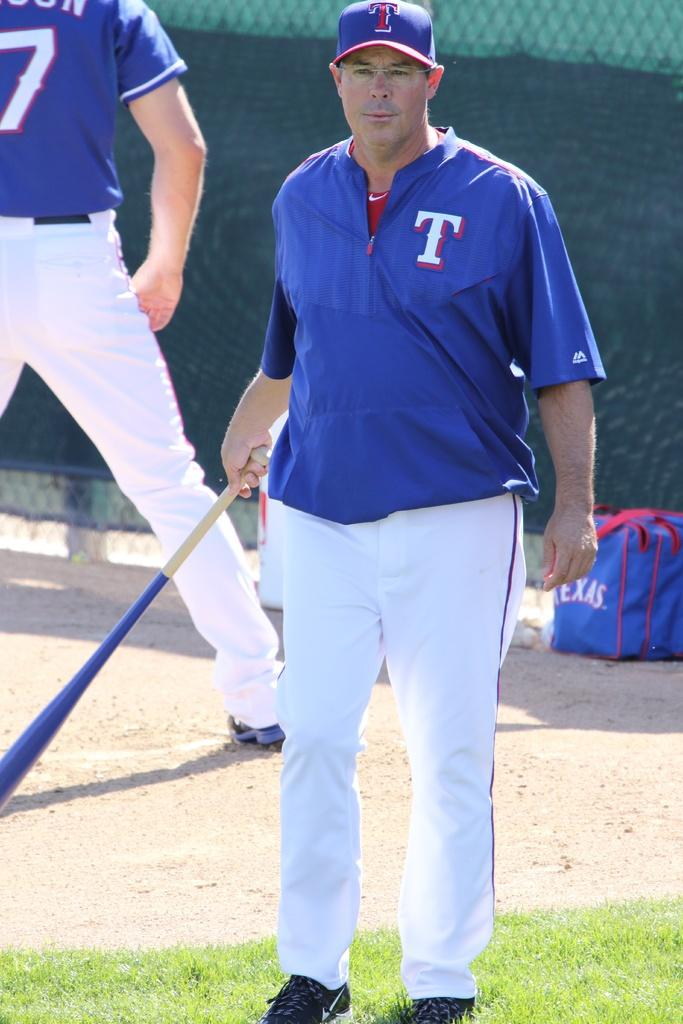Provide a one-sentence caption for the provided image. A baseball player with bat in hand wearing a blue shirt with a T on left shoulder and white pants. 